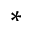Convert formula to latex. <formula><loc_0><loc_0><loc_500><loc_500>\ast</formula> 